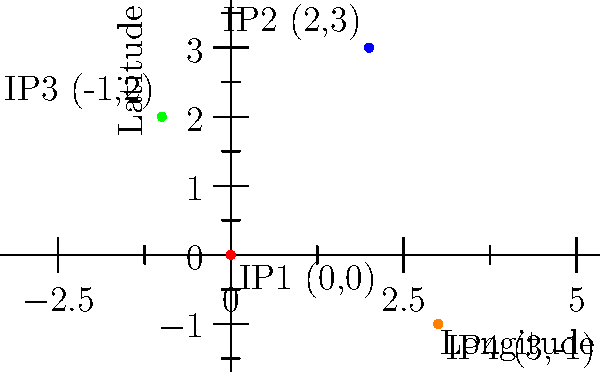As part of your online transaction security system, you're developing a feature to detect suspicious activities based on IP address locations. The system maps IP addresses to geographical coordinates (longitude, latitude). Given the coordinate plane above representing four IP addresses (IP1, IP2, IP3, IP4), calculate the Manhattan distance between IP1 and IP2. How would this distance metric be useful in identifying potential security threats? To solve this problem and understand its relevance to online transaction security, let's follow these steps:

1) Recall the formula for Manhattan distance:
   Manhattan distance = $|x_2 - x_1| + |y_2 - y_1|$

2) Identify the coordinates:
   IP1: (0, 0)
   IP2: (2, 3)

3) Calculate the distance:
   $|x_2 - x_1| = |2 - 0| = 2$
   $|y_2 - y_1| = |3 - 0| = 3$
   Manhattan distance = $2 + 3 = 5$

4) Relevance to security:
   The Manhattan distance provides a measure of how far apart two IP addresses are geographically. In the context of online transaction security:

   a) Sudden large distances between subsequent transactions from the same user account could indicate account takeover or unauthorized access.
   
   b) Transactions originating from IP addresses with unusually large distances from a user's typical location might be flagged for additional verification.
   
   c) Clustering of IP addresses within small distances could help identify bot networks or coordinated attacks.

   d) By establishing normal distance patterns for users, anomalies can be detected more easily, enhancing the overall security of the transaction system.
Answer: 5 units; useful for detecting geographical anomalies in user behavior 